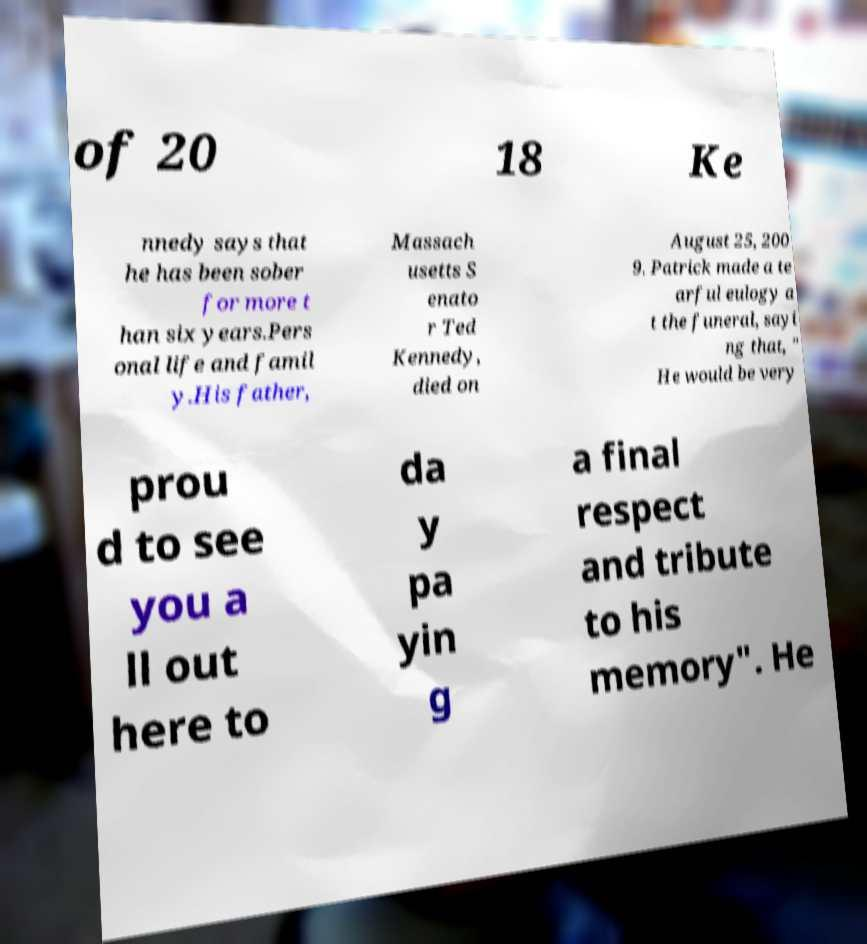Could you extract and type out the text from this image? of 20 18 Ke nnedy says that he has been sober for more t han six years.Pers onal life and famil y.His father, Massach usetts S enato r Ted Kennedy, died on August 25, 200 9. Patrick made a te arful eulogy a t the funeral, sayi ng that, " He would be very prou d to see you a ll out here to da y pa yin g a final respect and tribute to his memory". He 